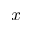Convert formula to latex. <formula><loc_0><loc_0><loc_500><loc_500>x</formula> 